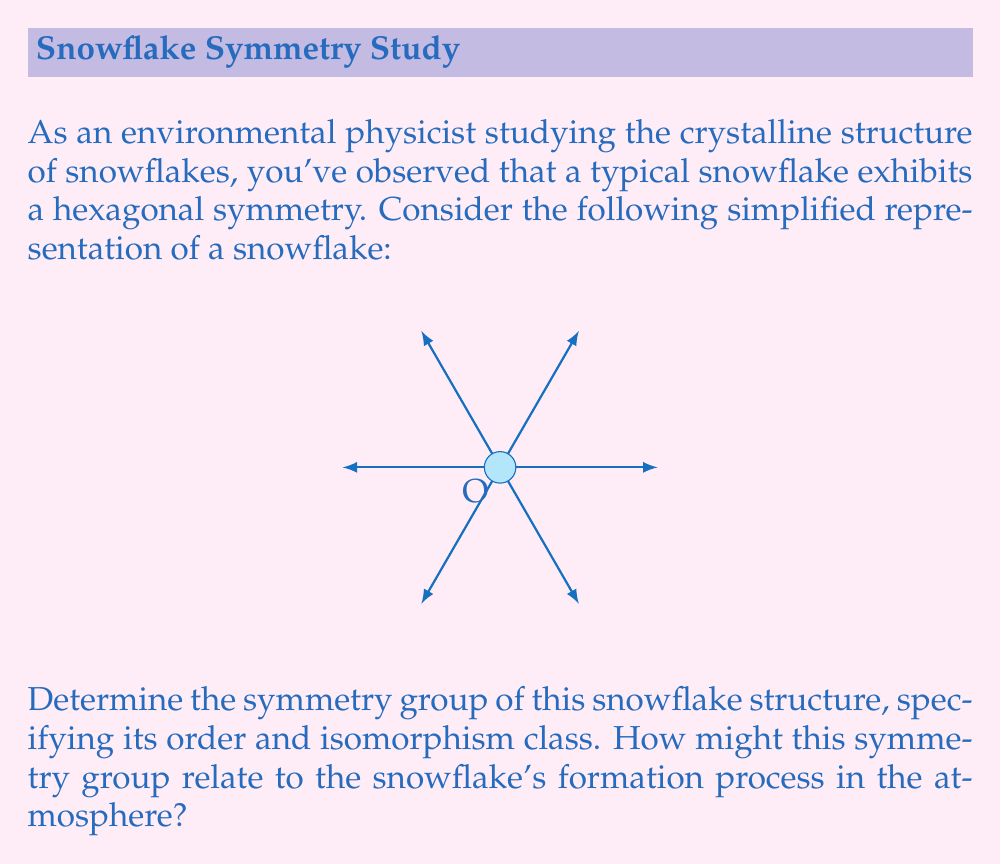Can you solve this math problem? To determine the symmetry group of the snowflake, we need to consider all the symmetry operations that leave the structure unchanged. Let's approach this step-by-step:

1) Rotational symmetry:
   The snowflake has 6-fold rotational symmetry. It remains unchanged when rotated by multiples of 60°. This gives us 6 rotational symmetries: 0°, 60°, 120°, 180°, 240°, and 300°.

2) Reflection symmetry:
   There are 6 lines of reflection symmetry, passing through the center and each of the 6 points of the snowflake.

3) Identity:
   The identity operation (doing nothing) is always a symmetry.

These symmetries form a group. Let's analyze this group:

4) Order of the group:
   Total number of symmetries = 6 (rotations) + 6 (reflections) + 1 (identity) = 13

5) Group structure:
   This group is isomorphic to the dihedral group of order 12, denoted as $D_6$ or $D_{12}$ (depending on the notation system).

6) Group properties:
   - It's non-abelian (rotations and reflections don't always commute)
   - It has 12 elements of order 2 (6 reflections and 6 rotations)
   - It has a cyclic subgroup of order 6 (the rotations)

7) Relation to snowflake formation:
   The hexagonal symmetry relates to the molecular structure of ice. Water molecules arrange themselves in a hexagonal lattice as they freeze, which is reflected in the macroscopic symmetry of the snowflake. The symmetry group $D_6$ captures this underlying hexagonal structure and the way the snowflake grows symmetrically in the atmosphere.

8) Group presentation:
   $D_6 = \langle r, s | r^6 = s^2 = 1, srs = r^{-1} \rangle$
   Where $r$ represents a 60° rotation and $s$ represents a reflection.
Answer: $D_6$ (or $D_{12}$), order 12, isomorphic to the dihedral group of order 12 